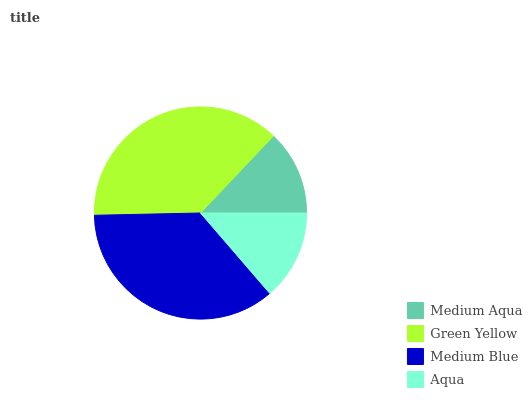Is Medium Aqua the minimum?
Answer yes or no. Yes. Is Green Yellow the maximum?
Answer yes or no. Yes. Is Medium Blue the minimum?
Answer yes or no. No. Is Medium Blue the maximum?
Answer yes or no. No. Is Green Yellow greater than Medium Blue?
Answer yes or no. Yes. Is Medium Blue less than Green Yellow?
Answer yes or no. Yes. Is Medium Blue greater than Green Yellow?
Answer yes or no. No. Is Green Yellow less than Medium Blue?
Answer yes or no. No. Is Medium Blue the high median?
Answer yes or no. Yes. Is Aqua the low median?
Answer yes or no. Yes. Is Green Yellow the high median?
Answer yes or no. No. Is Medium Aqua the low median?
Answer yes or no. No. 